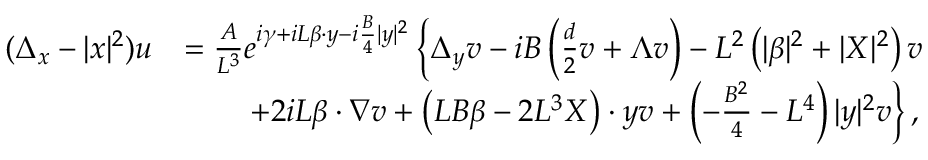<formula> <loc_0><loc_0><loc_500><loc_500>\begin{array} { r l } { ( \Delta _ { x } - | x | ^ { 2 } ) u } & { = \frac { A } { L ^ { 3 } } e ^ { i \gamma + i L \beta \cdot y - i \frac { B } { 4 } | y | ^ { 2 } } \left \{ \Delta _ { y } v - i B \left ( \frac { d } { 2 } v + \Lambda v \right ) - L ^ { 2 } \left ( | \beta | ^ { 2 } + | X | ^ { 2 } \right ) v } \\ & { \quad + 2 i L \beta \cdot \nabla v + \left ( L B \beta - 2 L ^ { 3 } X \right ) \cdot y v + \left ( - \frac { B ^ { 2 } } { 4 } - L ^ { 4 } \right ) | y | ^ { 2 } v \right \} , } \end{array}</formula> 